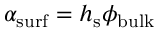<formula> <loc_0><loc_0><loc_500><loc_500>\alpha _ { s u r f } = h _ { s } \phi _ { b u l k }</formula> 